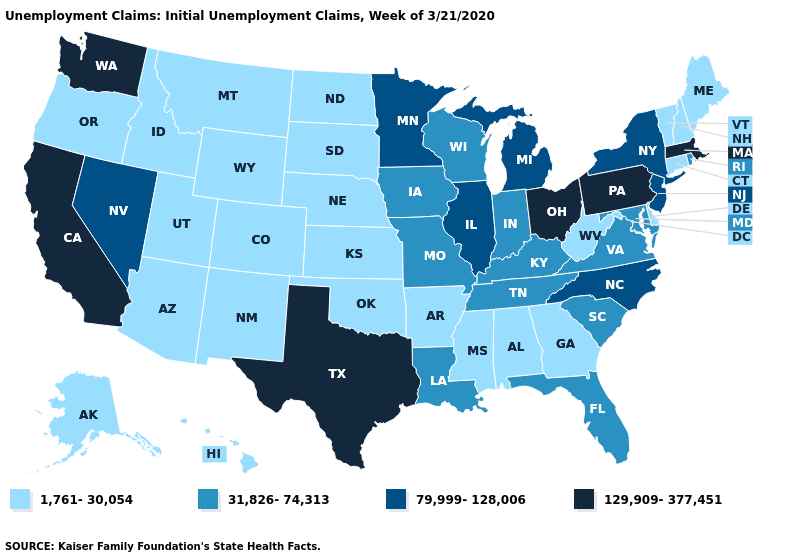What is the highest value in the USA?
Write a very short answer. 129,909-377,451. What is the lowest value in the MidWest?
Answer briefly. 1,761-30,054. Which states hav the highest value in the West?
Concise answer only. California, Washington. How many symbols are there in the legend?
Write a very short answer. 4. What is the lowest value in states that border Florida?
Be succinct. 1,761-30,054. Name the states that have a value in the range 31,826-74,313?
Keep it brief. Florida, Indiana, Iowa, Kentucky, Louisiana, Maryland, Missouri, Rhode Island, South Carolina, Tennessee, Virginia, Wisconsin. What is the value of Massachusetts?
Answer briefly. 129,909-377,451. Which states hav the highest value in the South?
Short answer required. Texas. What is the value of Oregon?
Write a very short answer. 1,761-30,054. Does the map have missing data?
Be succinct. No. What is the highest value in states that border Arkansas?
Concise answer only. 129,909-377,451. Among the states that border Mississippi , which have the highest value?
Short answer required. Louisiana, Tennessee. Which states hav the highest value in the South?
Quick response, please. Texas. Does Kansas have the lowest value in the MidWest?
Be succinct. Yes. What is the lowest value in the Northeast?
Be succinct. 1,761-30,054. 